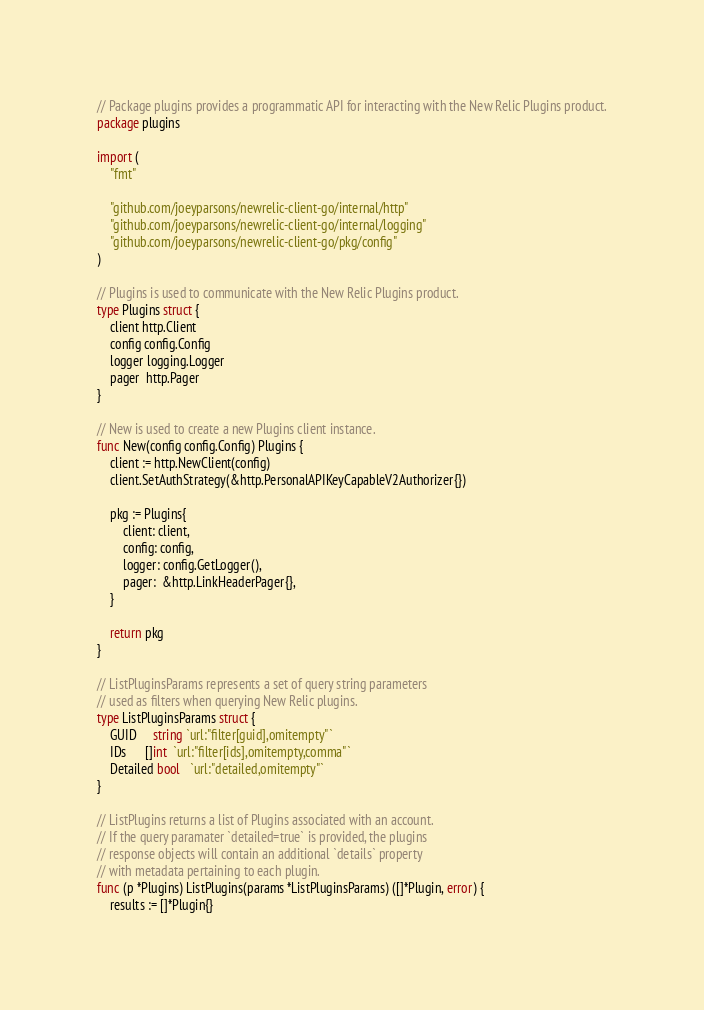Convert code to text. <code><loc_0><loc_0><loc_500><loc_500><_Go_>// Package plugins provides a programmatic API for interacting with the New Relic Plugins product.
package plugins

import (
	"fmt"

	"github.com/joeyparsons/newrelic-client-go/internal/http"
	"github.com/joeyparsons/newrelic-client-go/internal/logging"
	"github.com/joeyparsons/newrelic-client-go/pkg/config"
)

// Plugins is used to communicate with the New Relic Plugins product.
type Plugins struct {
	client http.Client
	config config.Config
	logger logging.Logger
	pager  http.Pager
}

// New is used to create a new Plugins client instance.
func New(config config.Config) Plugins {
	client := http.NewClient(config)
	client.SetAuthStrategy(&http.PersonalAPIKeyCapableV2Authorizer{})

	pkg := Plugins{
		client: client,
		config: config,
		logger: config.GetLogger(),
		pager:  &http.LinkHeaderPager{},
	}

	return pkg
}

// ListPluginsParams represents a set of query string parameters
// used as filters when querying New Relic plugins.
type ListPluginsParams struct {
	GUID     string `url:"filter[guid],omitempty"`
	IDs      []int  `url:"filter[ids],omitempty,comma"`
	Detailed bool   `url:"detailed,omitempty"`
}

// ListPlugins returns a list of Plugins associated with an account.
// If the query paramater `detailed=true` is provided, the plugins
// response objects will contain an additional `details` property
// with metadata pertaining to each plugin.
func (p *Plugins) ListPlugins(params *ListPluginsParams) ([]*Plugin, error) {
	results := []*Plugin{}</code> 